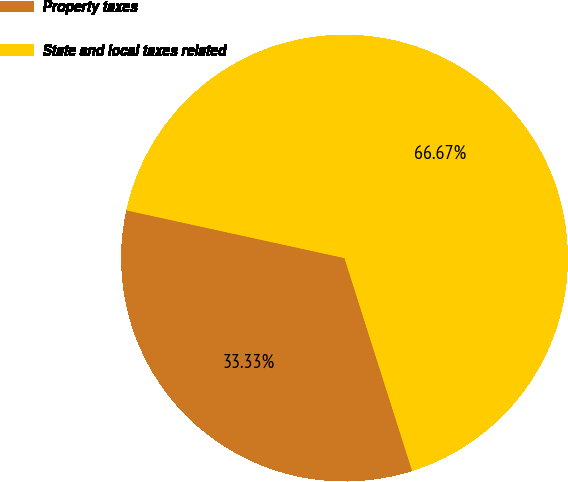Convert chart to OTSL. <chart><loc_0><loc_0><loc_500><loc_500><pie_chart><fcel>Property taxes<fcel>State and local taxes related<nl><fcel>33.33%<fcel>66.67%<nl></chart> 